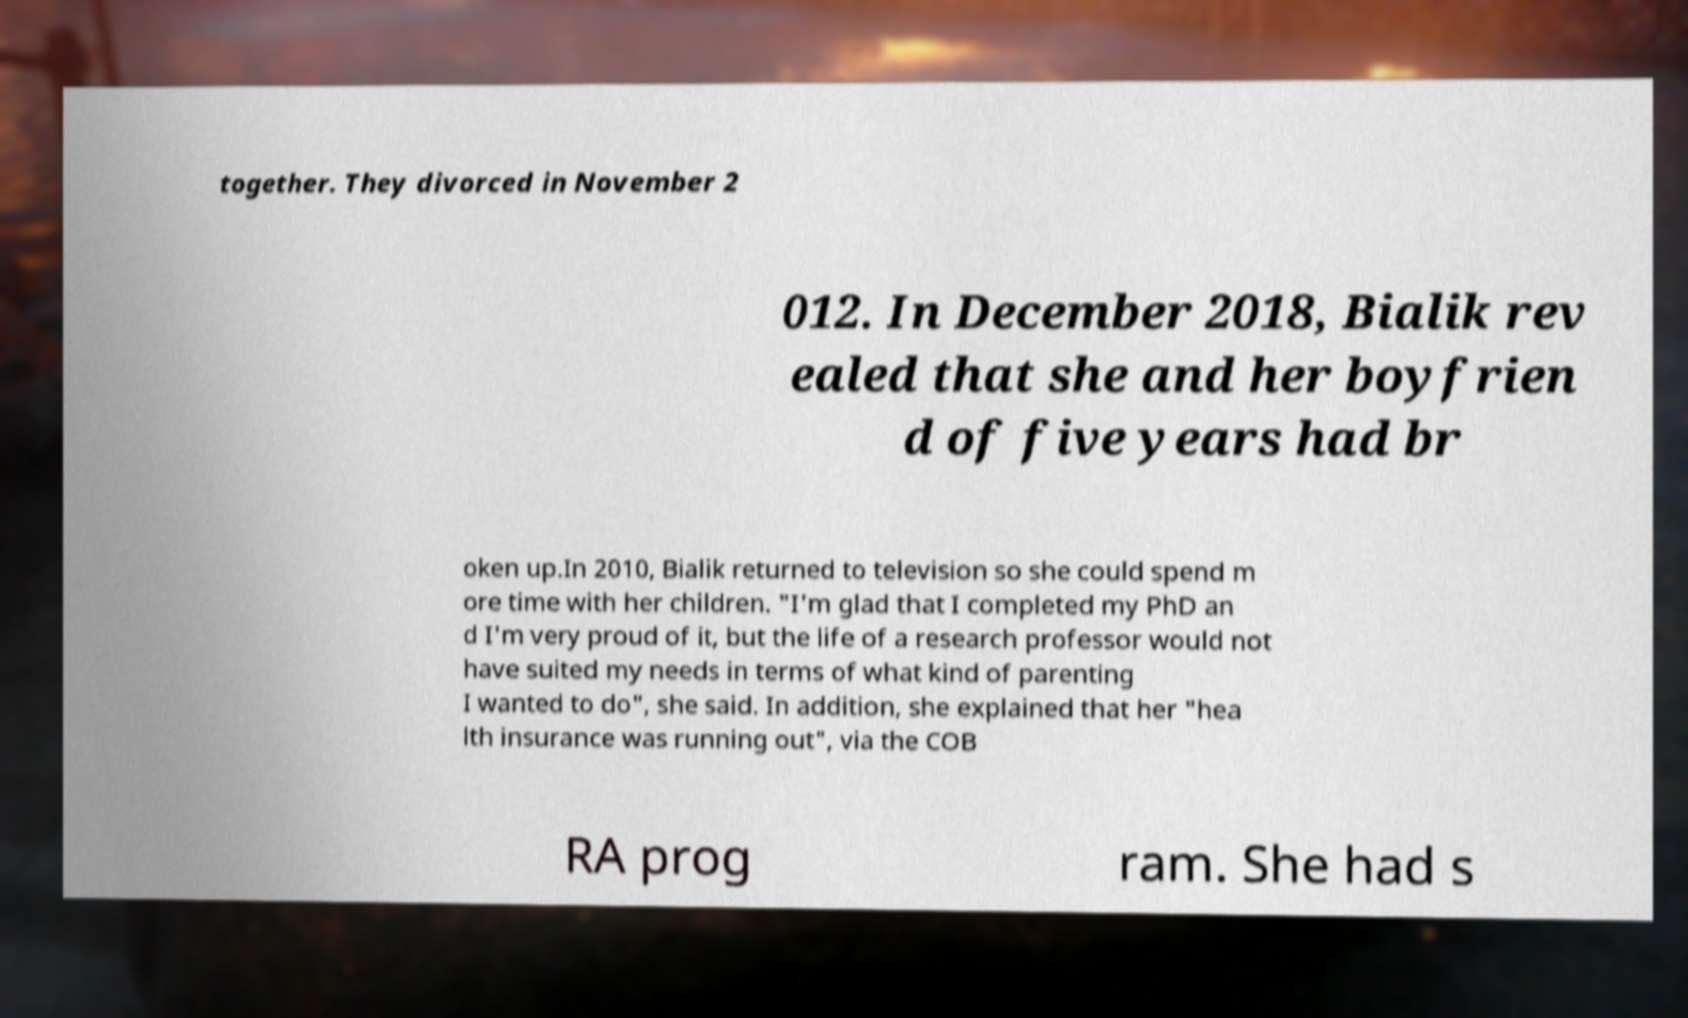Can you read and provide the text displayed in the image?This photo seems to have some interesting text. Can you extract and type it out for me? together. They divorced in November 2 012. In December 2018, Bialik rev ealed that she and her boyfrien d of five years had br oken up.In 2010, Bialik returned to television so she could spend m ore time with her children. "I'm glad that I completed my PhD an d I'm very proud of it, but the life of a research professor would not have suited my needs in terms of what kind of parenting I wanted to do", she said. In addition, she explained that her "hea lth insurance was running out", via the COB RA prog ram. She had s 